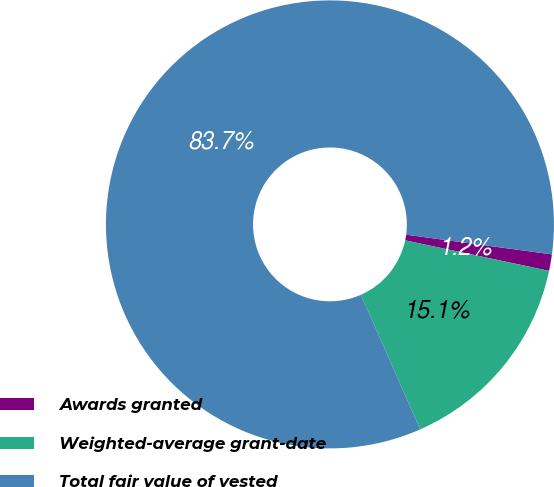Convert chart to OTSL. <chart><loc_0><loc_0><loc_500><loc_500><pie_chart><fcel>Awards granted<fcel>Weighted-average grant-date<fcel>Total fair value of vested<nl><fcel>1.19%<fcel>15.07%<fcel>83.74%<nl></chart> 